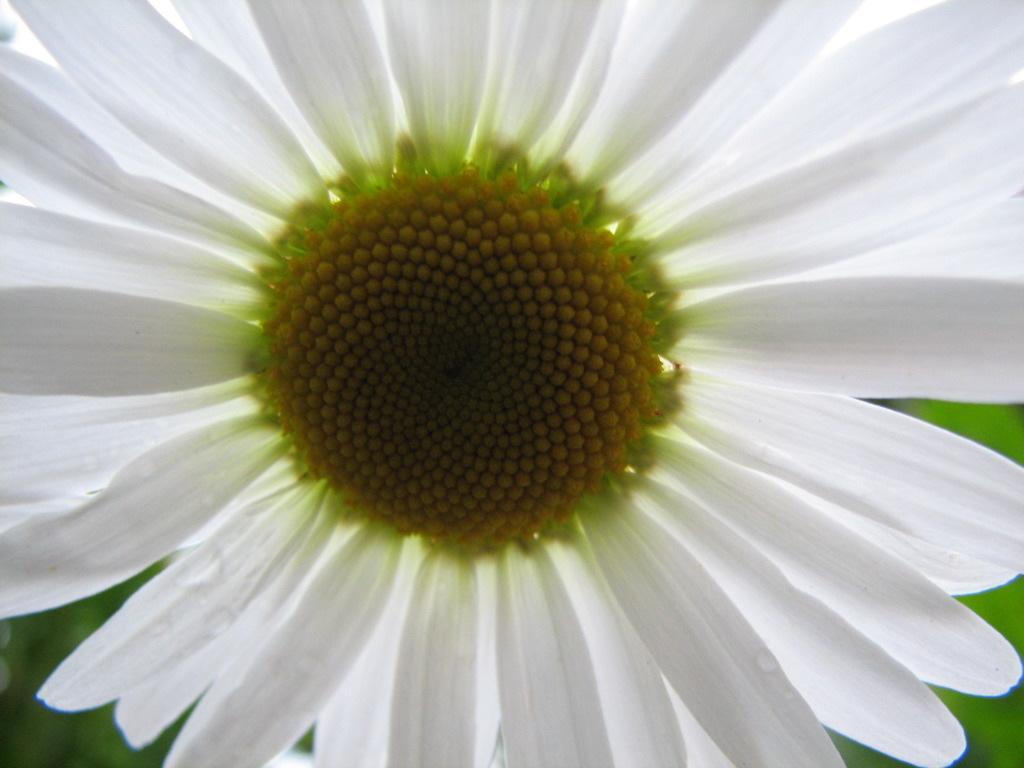In one or two sentences, can you explain what this image depicts? In this image, we can see a flower and the blurred background. 